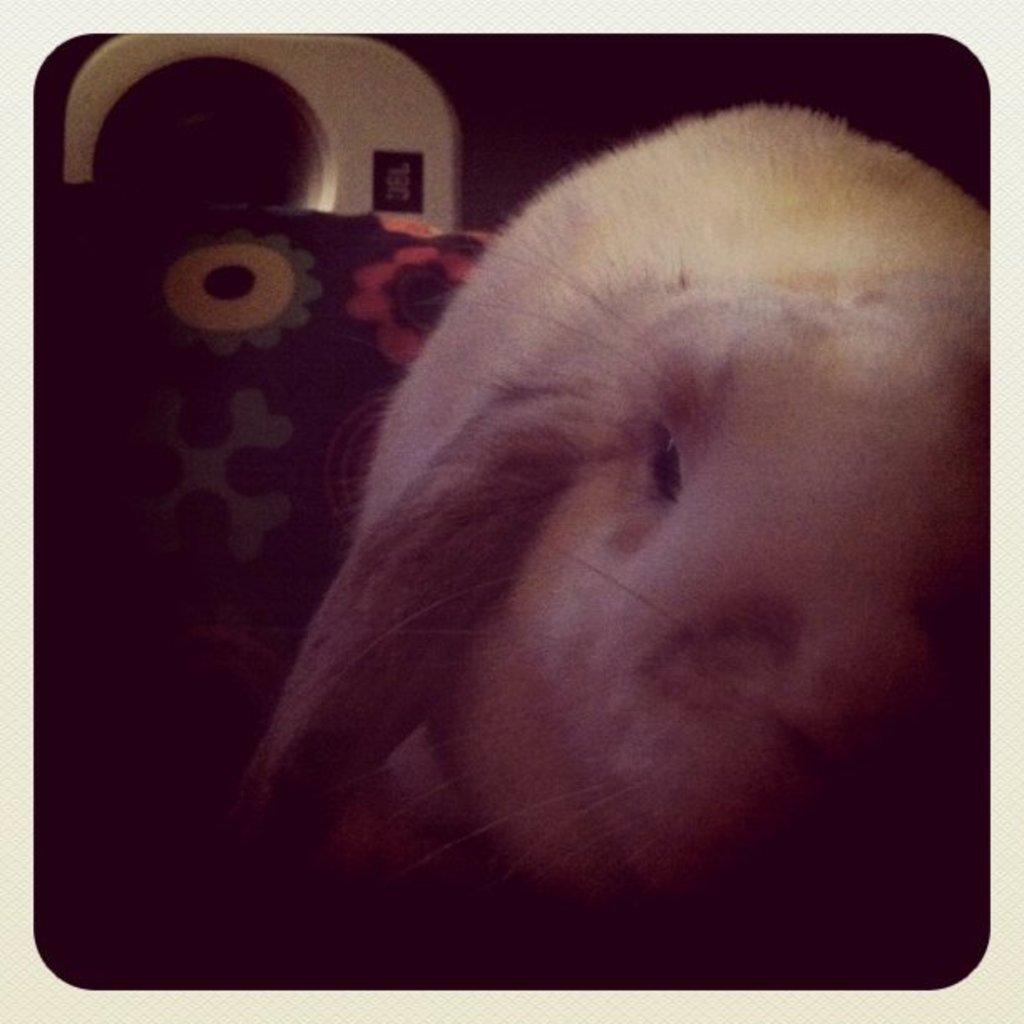What type of animal is in the image? There is a rabbit in the image. What can be seen in the background of the image? There is a cloth in the background of the image. Can you describe the unspecified object in the image? Unfortunately, the facts provided do not give enough information to describe the unspecified object in the image. What type of cactus is present at the party in the image? There is no cactus or party present in the image; it features a rabbit and a cloth in the background. How many people are laughing in the image? There are no people or laughter present in the image. 